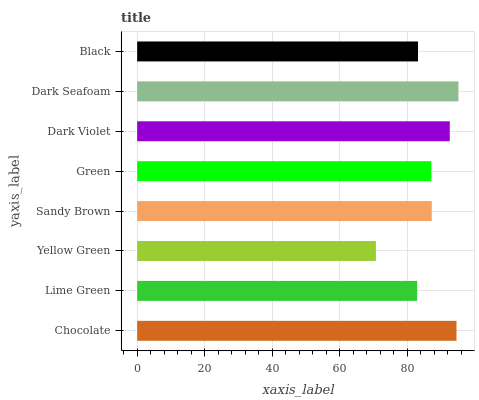Is Yellow Green the minimum?
Answer yes or no. Yes. Is Dark Seafoam the maximum?
Answer yes or no. Yes. Is Lime Green the minimum?
Answer yes or no. No. Is Lime Green the maximum?
Answer yes or no. No. Is Chocolate greater than Lime Green?
Answer yes or no. Yes. Is Lime Green less than Chocolate?
Answer yes or no. Yes. Is Lime Green greater than Chocolate?
Answer yes or no. No. Is Chocolate less than Lime Green?
Answer yes or no. No. Is Sandy Brown the high median?
Answer yes or no. Yes. Is Green the low median?
Answer yes or no. Yes. Is Lime Green the high median?
Answer yes or no. No. Is Sandy Brown the low median?
Answer yes or no. No. 